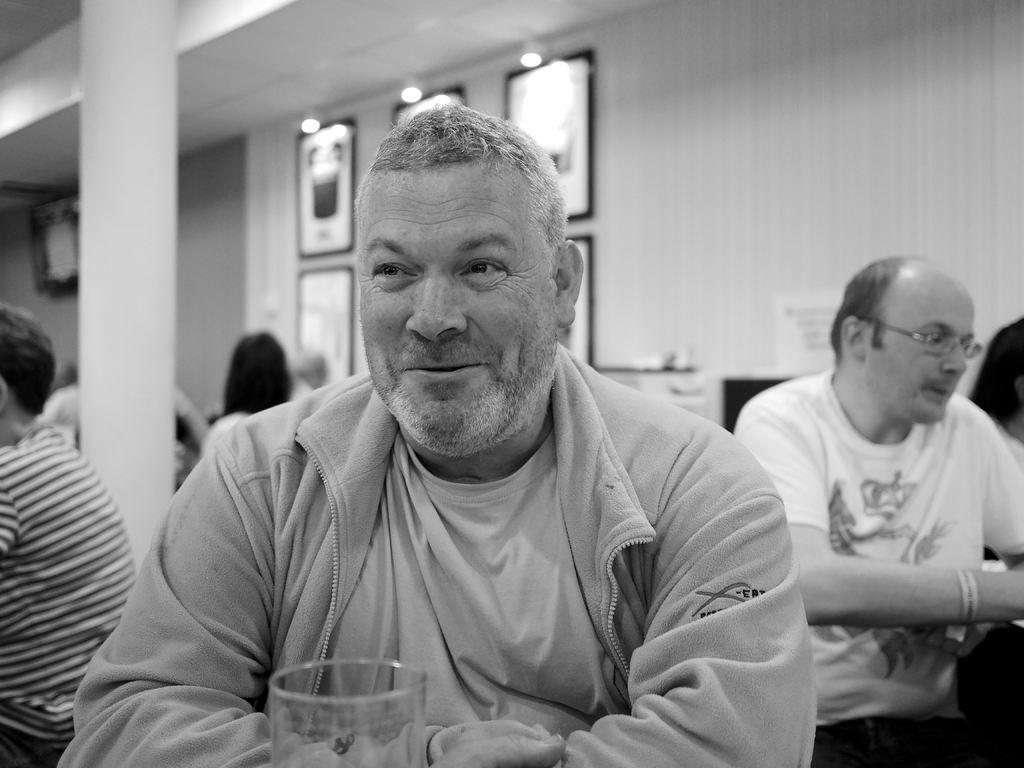What is the person in the image doing? The person in the image is sitting and smiling. What object can be seen near the person? There is a glass in the image. How many people are sitting in the image? There is a group of people sitting in the image. What can be seen on the wall in the background of the image? There are frames attached to the wall in the background of the image. What type of lighting is present in the background of the image? There are lights in the background of the image. What type of anger is the person expressing in the image? The person in the image is not expressing anger; they are smiling. Can you tell me how many cannons are present in the image? There are no cannons present in the image. 